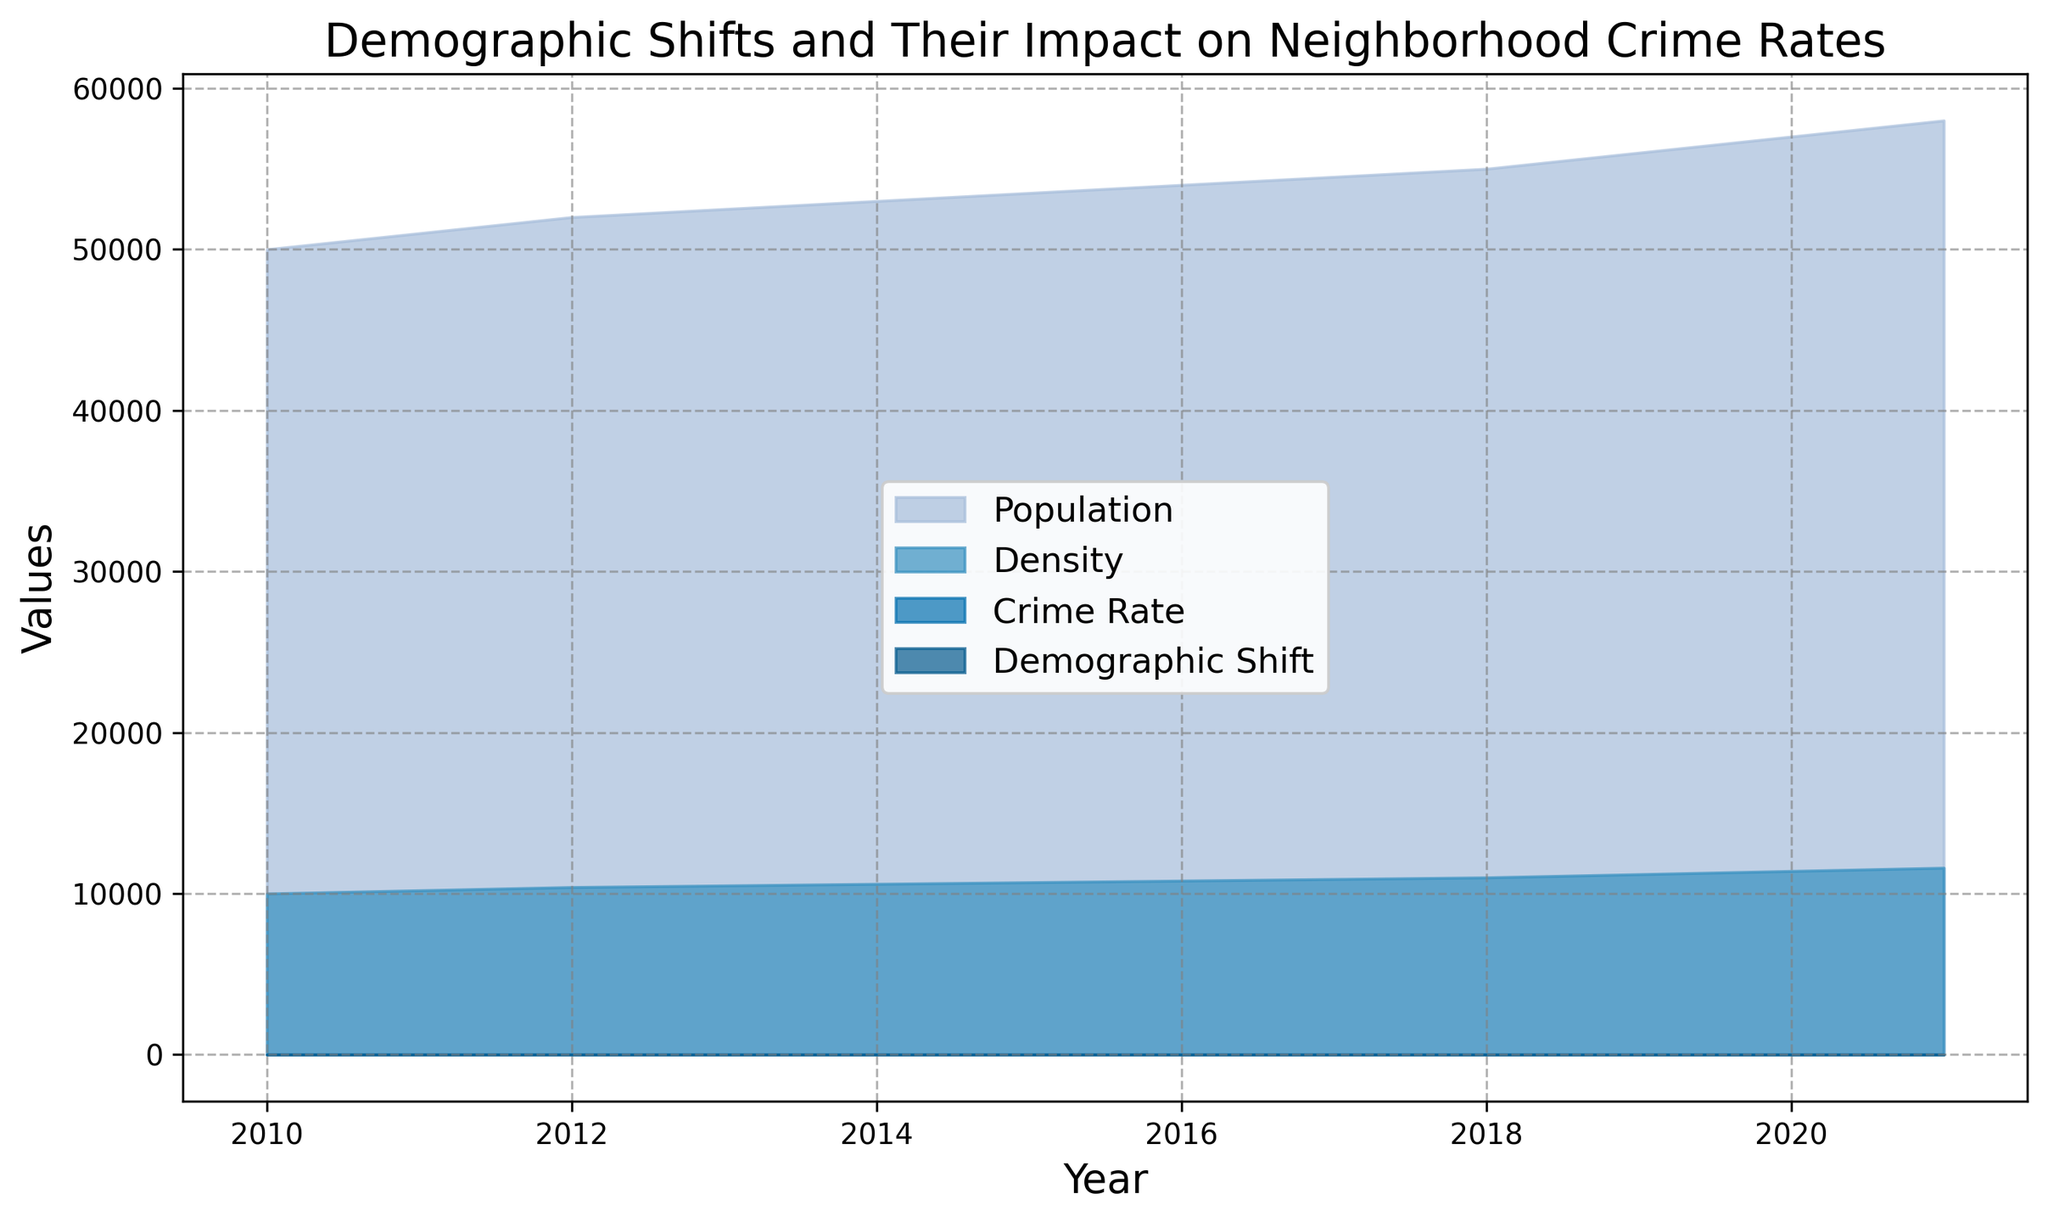What is the trend of Demographic Shift from 2010 to 2021? The Demographic Shift data shows an initial slight increase, followed by a gradual decline until 2018, and then a moderate increase again towards 2021. This can be observed by examining the heights of the shaded area representing the Demographic Shift over the years.
Answer: Initial rise, then decline, then moderate increase Between 2015 and 2017, how did the Crime Rate change, and what might be inferred from this trend? From 2015 to 2017, the Crime Rate decreased from 5.2 to 4.8, as shown by the downward slope of the area covered by the Crime Rate data. This trend might infer improved policing or other factors leading to decreased crime.
Answer: Decreased from 5.2 to 4.8 Which data category had the most significant change between 2010 and 2021? By comparing the areas and respective heights for each year, the Population shows the most significant increase, from 50,000 to 58,000, representing a constant upward trend.
Answer: Population How does the trend of Population relate to the Crime Rate over the observed period? The Population exhibits a steady increase from 2010 to 2021. Conversely, the Crime Rate shows fluctuations, increasing and decreasing throughout the period. This indicates that Population growth does not directly correlate with Crime Rate increases.
Answer: Population steadily increases, Crime Rate fluctuates What year saw the highest Density, and what was the value? The year 2021 saw the highest Density, represented by the highest point in the shaded area for Density, with a value of 11600.
Answer: 2021, 11600 Compare the rate of change in Crime Rate and Demographic Shift from 2013 to 2015. Between 2013 and 2015, the Crime Rate increased from 5.3 to 5.2, while the Demographic Shift increased from 0.2 to 0.22. The rates of change are relatively slow but positive for both metrics during this period.
Answer: Crime Rate: +0.1, Demographic Shift: +0.02 From the area chart, identify which year has the lowest Crime Rate and state its value. The lowest Crime Rate is visible at the point where the lowest part of the area corresponding to Crime Rate is in the year 2018, with a value of 4.6.
Answer: 2018, 4.6 During which years did the Demographic Shift remain constant, and what was that value? The Demographic Shift remained constant between 2010 and 2011, and again between 2017 and 2018, with values of 0.2 and 0.15 respectively, as indicated by the flat parts of the shaded area.
Answer: 2010-2011 (0.2), 2017-2018 (0.15) 